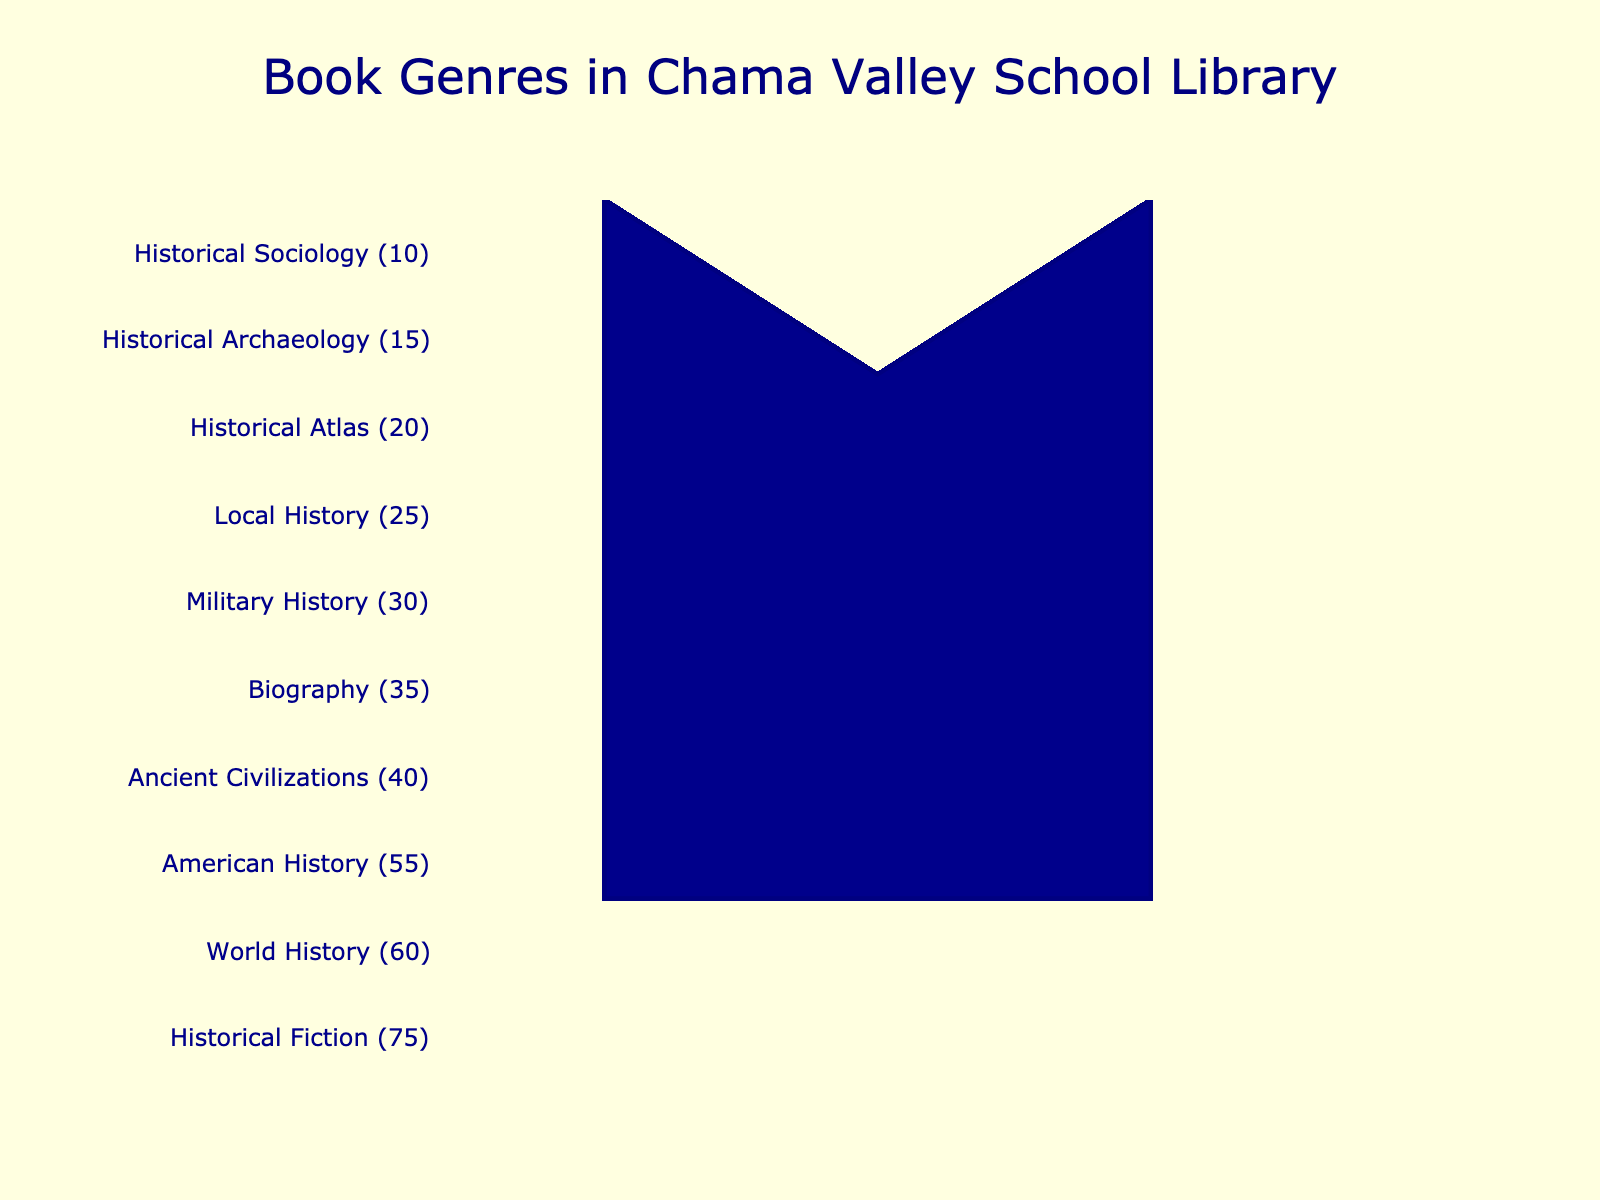What is the genre with the most books in the Chama Valley school library? The genre with the most books is the one with the highest number of icons in the Isotype Plot. Historical Fiction has the most icons.
Answer: Historical Fiction Which genre has fewer books, Ancient Civilizations or Biography? Count the number of icons for each genre in the figure. Ancient Civilizations has 8 icons, and Biography has 7 icons. Therefore, Biography has fewer books than Ancient Civilizations.
Answer: Biography How many total history-related books are there in total? Sum the book counts for all the history-related genres. The genres and their counts are: World History (60), American History (55), Ancient Civilizations (40), Military History (30), Local History (25), Historical Atlas (20), Historical Archaeology (15), and Historical Sociology (10). Therefore, the total is 60 + 55 + 40 + 30 + 25 + 20 + 15 + 10 = 255 books.
Answer: 255 Which genre has the least number of books? Identify the genre with the fewest icons. Historical Sociology has the least number of books, with only 10.
Answer: Historical Sociology How many more books does Historical Fiction have than World History? Find the difference between the number of books in these two genres. Historical Fiction has 75 books, and World History has 60 books. The difference is 75 - 60 = 15 books.
Answer: 15 Which genre has a higher count, Biography or Military History? Compare the number of books in each genre by counting the icons. Biography has 7 icons (35 books) and Military History has 6 icons (30 books). Therefore, Biography has a higher count.
Answer: Biography What is the combined total number of books in Historical Fiction, World History, and American History? Sum the books in these three genres. Historical Fiction has 75, World History has 60, and American History has 55. So, the total is 75 + 60 + 55 = 190 books.
Answer: 190 What percentage of the total book count does American History represent within these history-related genres? First, find the total number of books in all history-related genres (255). Then calculate the percentage of American History within that total: (American History books / total history books) * 100 = (55 / 255) * 100 ≈ 21.57%.
Answer: 21.57% What is the median book count among the given genres? List all counts in ascending order: 10, 15, 20, 25, 30, 35, 40, 55, 60, 75. The median is the average of the 5th and 6th values: (30 + 35) / 2 = 32.5 books.
Answer: 32.5 books 